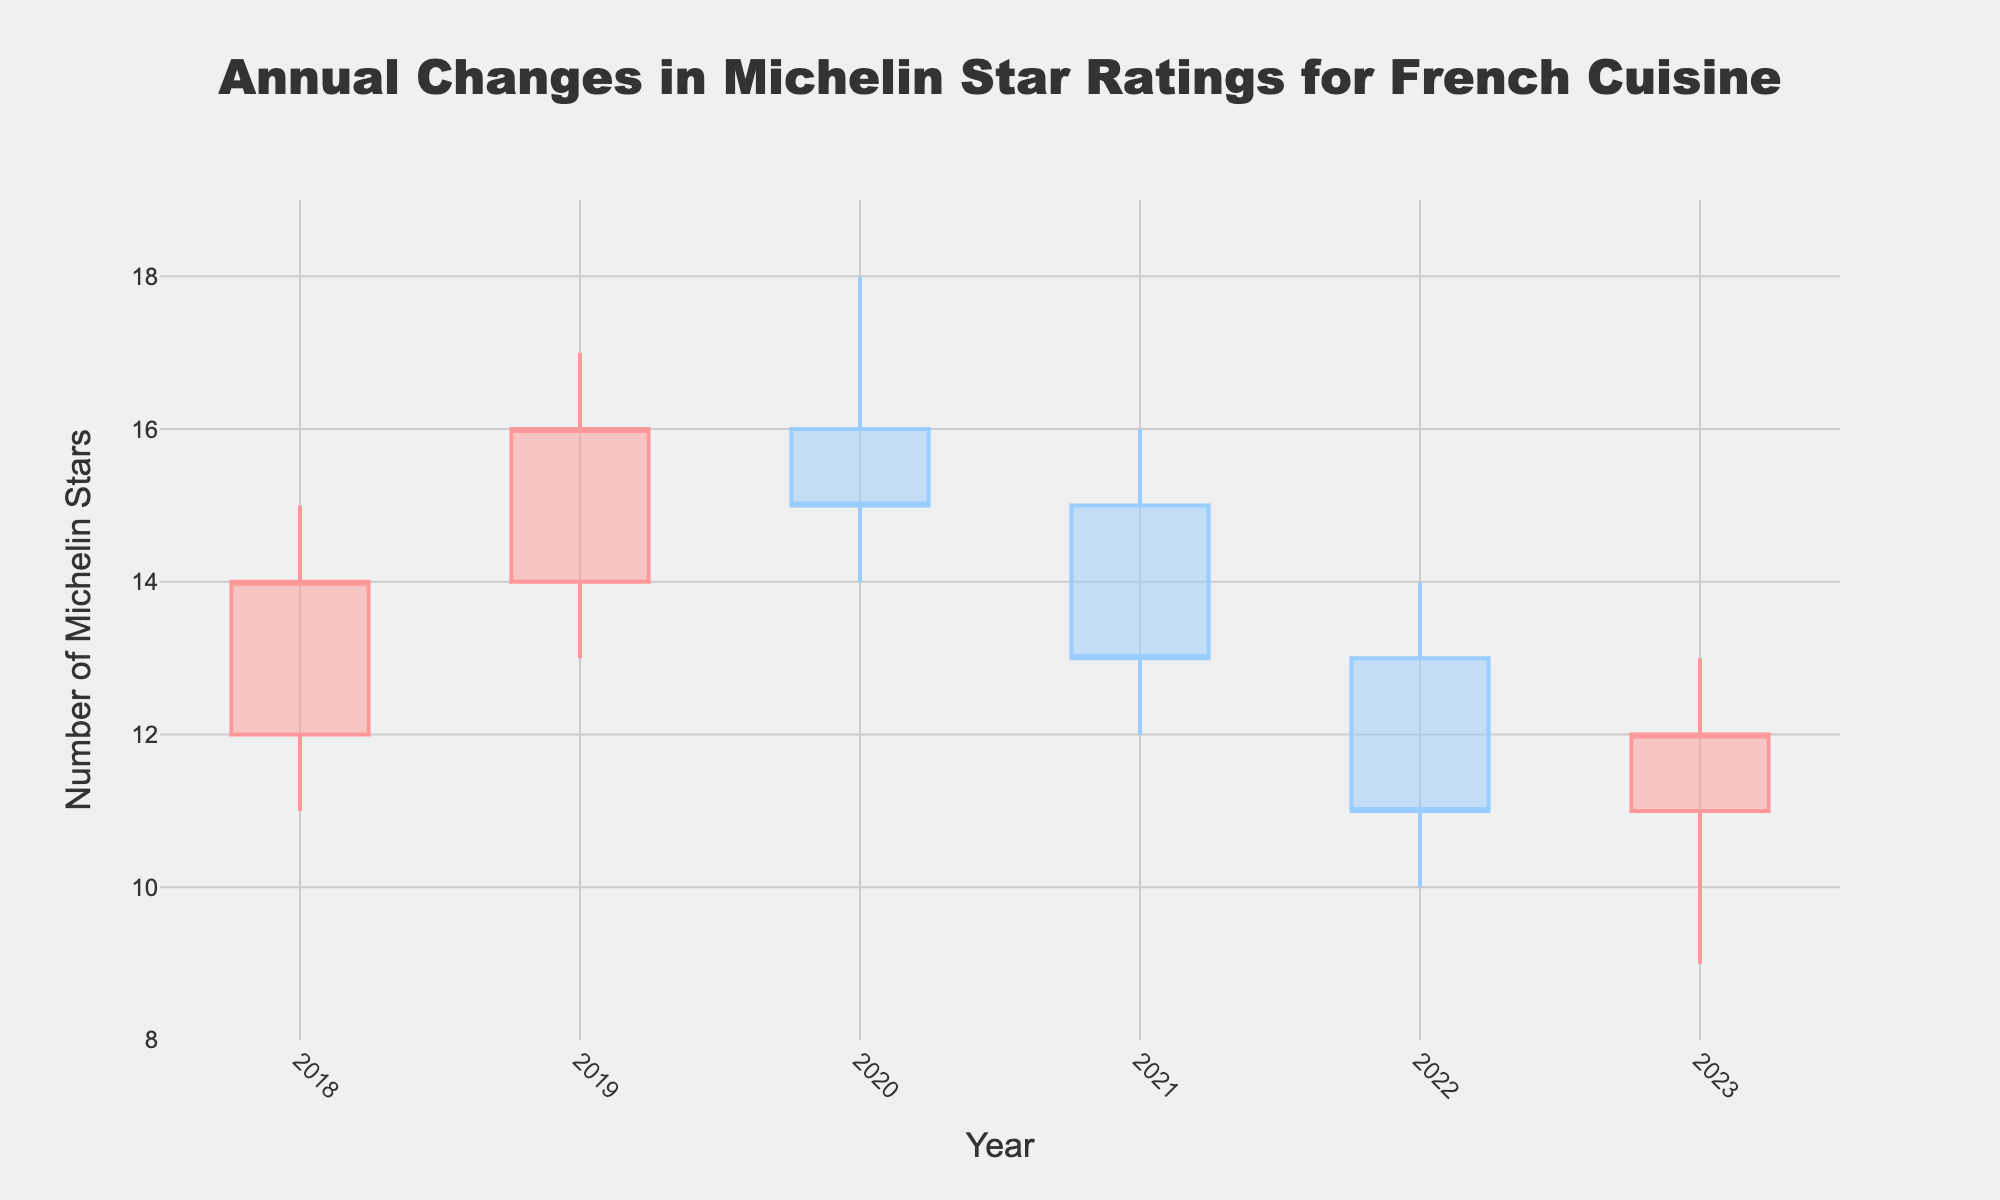What is the title of the figure? The title can be identified at the top center of the figure. It reads 'Annual Changes in Michelin Star Ratings for French Cuisine'.
Answer: Annual Changes in Michelin Star Ratings for French Cuisine Which year experienced the highest initial star count? Examine the 'open' values for each year. The year 2020 has the highest initial star count of 16.
Answer: 2020 What are the highest and lowest star counts in 2021? The highest and lowest values for 2021 are indicated by the top and bottom of the candlestick bar for that year. The highest star count is 16, and the lowest is 12.
Answer: 16, 12 Which year shows the largest drop from initial to final star count? Calculate the difference between initial and final star counts for each year: 2018 (−2), 2019 (+2), 2020 (-1), 2021 (−2), 2022 (−2), 2023 (+1). The largest drop is in 2021, with a drop from 15 to 13 stars.
Answer: 2021 In what year was the final star count the same as the initial count? Looking for when the 'open' value equals the 'close' value, this occurs when both the initial and final counts are equal. This doesn't occur in any of the given years.
Answer: None What is the trend in the final star counts over the six years? Examine the final star counts year by year: 2018 (14), 2019 (16), 2020 (15), 2021 (13), 2022 (11), 2023 (12). The trend shows a general decrease over the six years.
Answer: Decreasing Which year experienced both the highest and lowest star counts within the same year? This is the year where the divergence between the highest and lowest star counts is the greatest. For 2020, the highest is 18 and the lowest is 14, a difference of 4.
Answer: 2020 What was the star count at the end of 2019? Look at the closing value for the year 2019, which is the final star count. It is 16.
Answer: 16 Which year had the highest maximum star count and what was it? Identify the highest 'high' value in the chart, which is 18 in the year 2020.
Answer: 2020, 18 